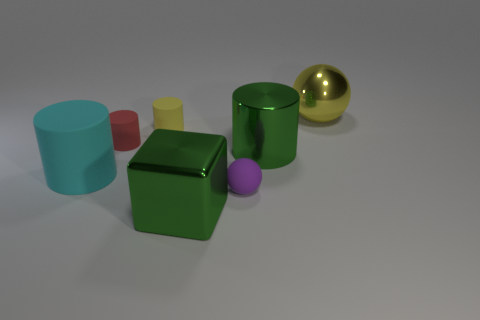Add 2 red matte objects. How many objects exist? 9 Subtract all large green cylinders. How many cylinders are left? 3 Subtract all red cylinders. How many cylinders are left? 3 Subtract all balls. How many objects are left? 5 Subtract 1 balls. How many balls are left? 1 Subtract all tiny brown rubber spheres. Subtract all cyan rubber things. How many objects are left? 6 Add 7 small yellow rubber cylinders. How many small yellow rubber cylinders are left? 8 Add 6 red things. How many red things exist? 7 Subtract 0 brown cylinders. How many objects are left? 7 Subtract all red spheres. Subtract all gray cubes. How many spheres are left? 2 